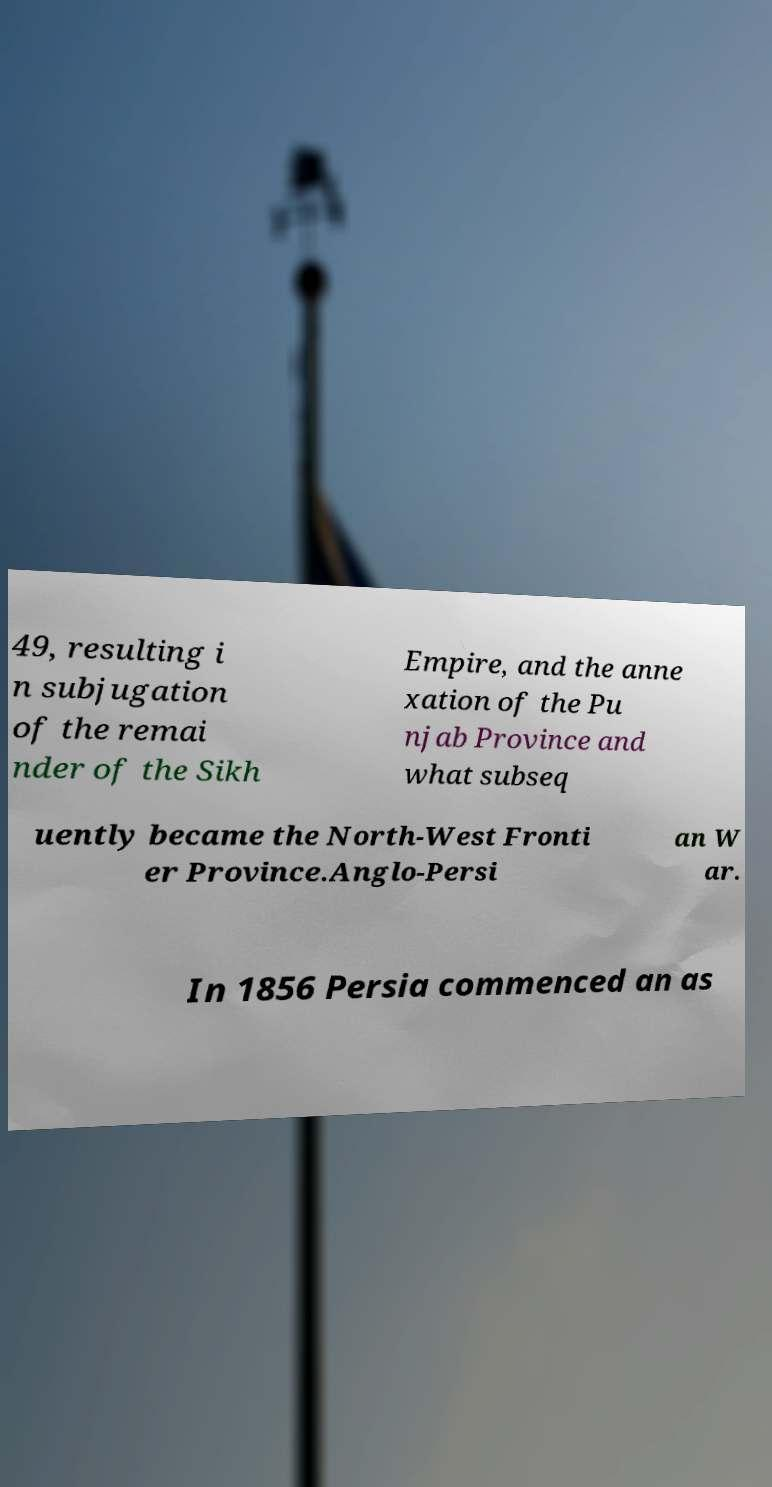I need the written content from this picture converted into text. Can you do that? 49, resulting i n subjugation of the remai nder of the Sikh Empire, and the anne xation of the Pu njab Province and what subseq uently became the North-West Fronti er Province.Anglo-Persi an W ar. In 1856 Persia commenced an as 